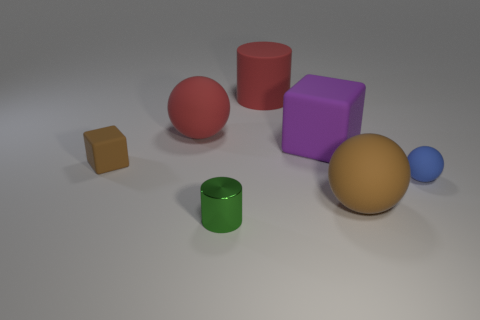What time of day does the lighting in the image suggest? The soft shadows and neutral lighting in the image do not strongly suggest any particular time of day. It seems to be an evenly lit studio setting with artificial lighting designed to minimize harsh shadows. Do the objects appear to be arranged in any particular pattern? There is no apparent deliberate pattern to the arrangement of objects; they seem to be placed randomly on the surface. The varying distances between them create an impression of randomness rather than an organized pattern. 